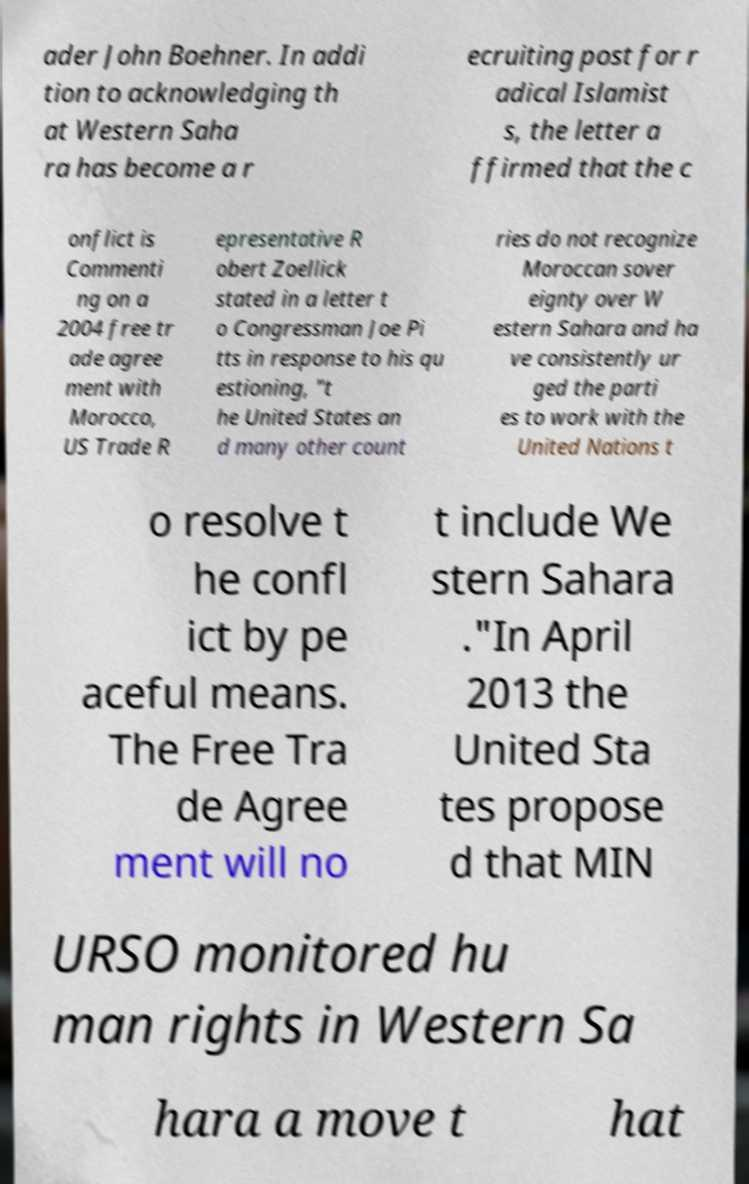There's text embedded in this image that I need extracted. Can you transcribe it verbatim? ader John Boehner. In addi tion to acknowledging th at Western Saha ra has become a r ecruiting post for r adical Islamist s, the letter a ffirmed that the c onflict is Commenti ng on a 2004 free tr ade agree ment with Morocco, US Trade R epresentative R obert Zoellick stated in a letter t o Congressman Joe Pi tts in response to his qu estioning, "t he United States an d many other count ries do not recognize Moroccan sover eignty over W estern Sahara and ha ve consistently ur ged the parti es to work with the United Nations t o resolve t he confl ict by pe aceful means. The Free Tra de Agree ment will no t include We stern Sahara ."In April 2013 the United Sta tes propose d that MIN URSO monitored hu man rights in Western Sa hara a move t hat 